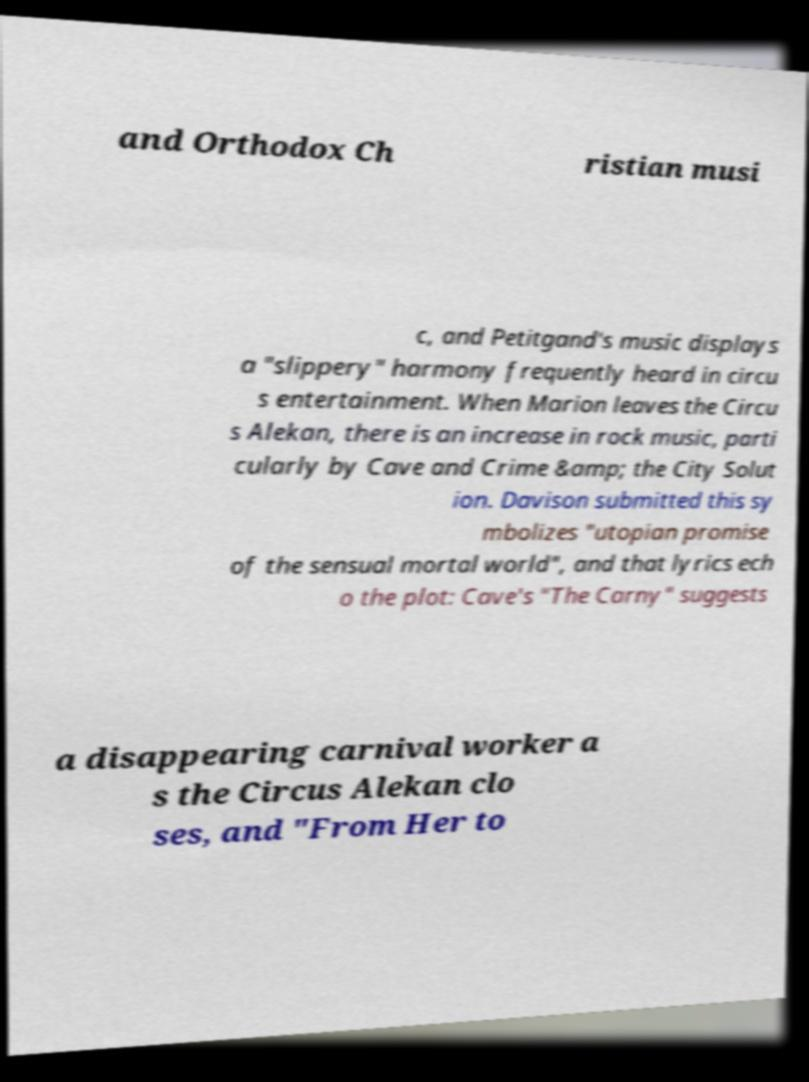Can you accurately transcribe the text from the provided image for me? and Orthodox Ch ristian musi c, and Petitgand's music displays a "slippery" harmony frequently heard in circu s entertainment. When Marion leaves the Circu s Alekan, there is an increase in rock music, parti cularly by Cave and Crime &amp; the City Solut ion. Davison submitted this sy mbolizes "utopian promise of the sensual mortal world", and that lyrics ech o the plot: Cave's "The Carny" suggests a disappearing carnival worker a s the Circus Alekan clo ses, and "From Her to 